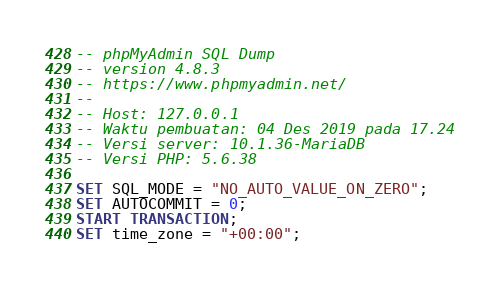Convert code to text. <code><loc_0><loc_0><loc_500><loc_500><_SQL_>-- phpMyAdmin SQL Dump
-- version 4.8.3
-- https://www.phpmyadmin.net/
--
-- Host: 127.0.0.1
-- Waktu pembuatan: 04 Des 2019 pada 17.24
-- Versi server: 10.1.36-MariaDB
-- Versi PHP: 5.6.38

SET SQL_MODE = "NO_AUTO_VALUE_ON_ZERO";
SET AUTOCOMMIT = 0;
START TRANSACTION;
SET time_zone = "+00:00";

</code> 